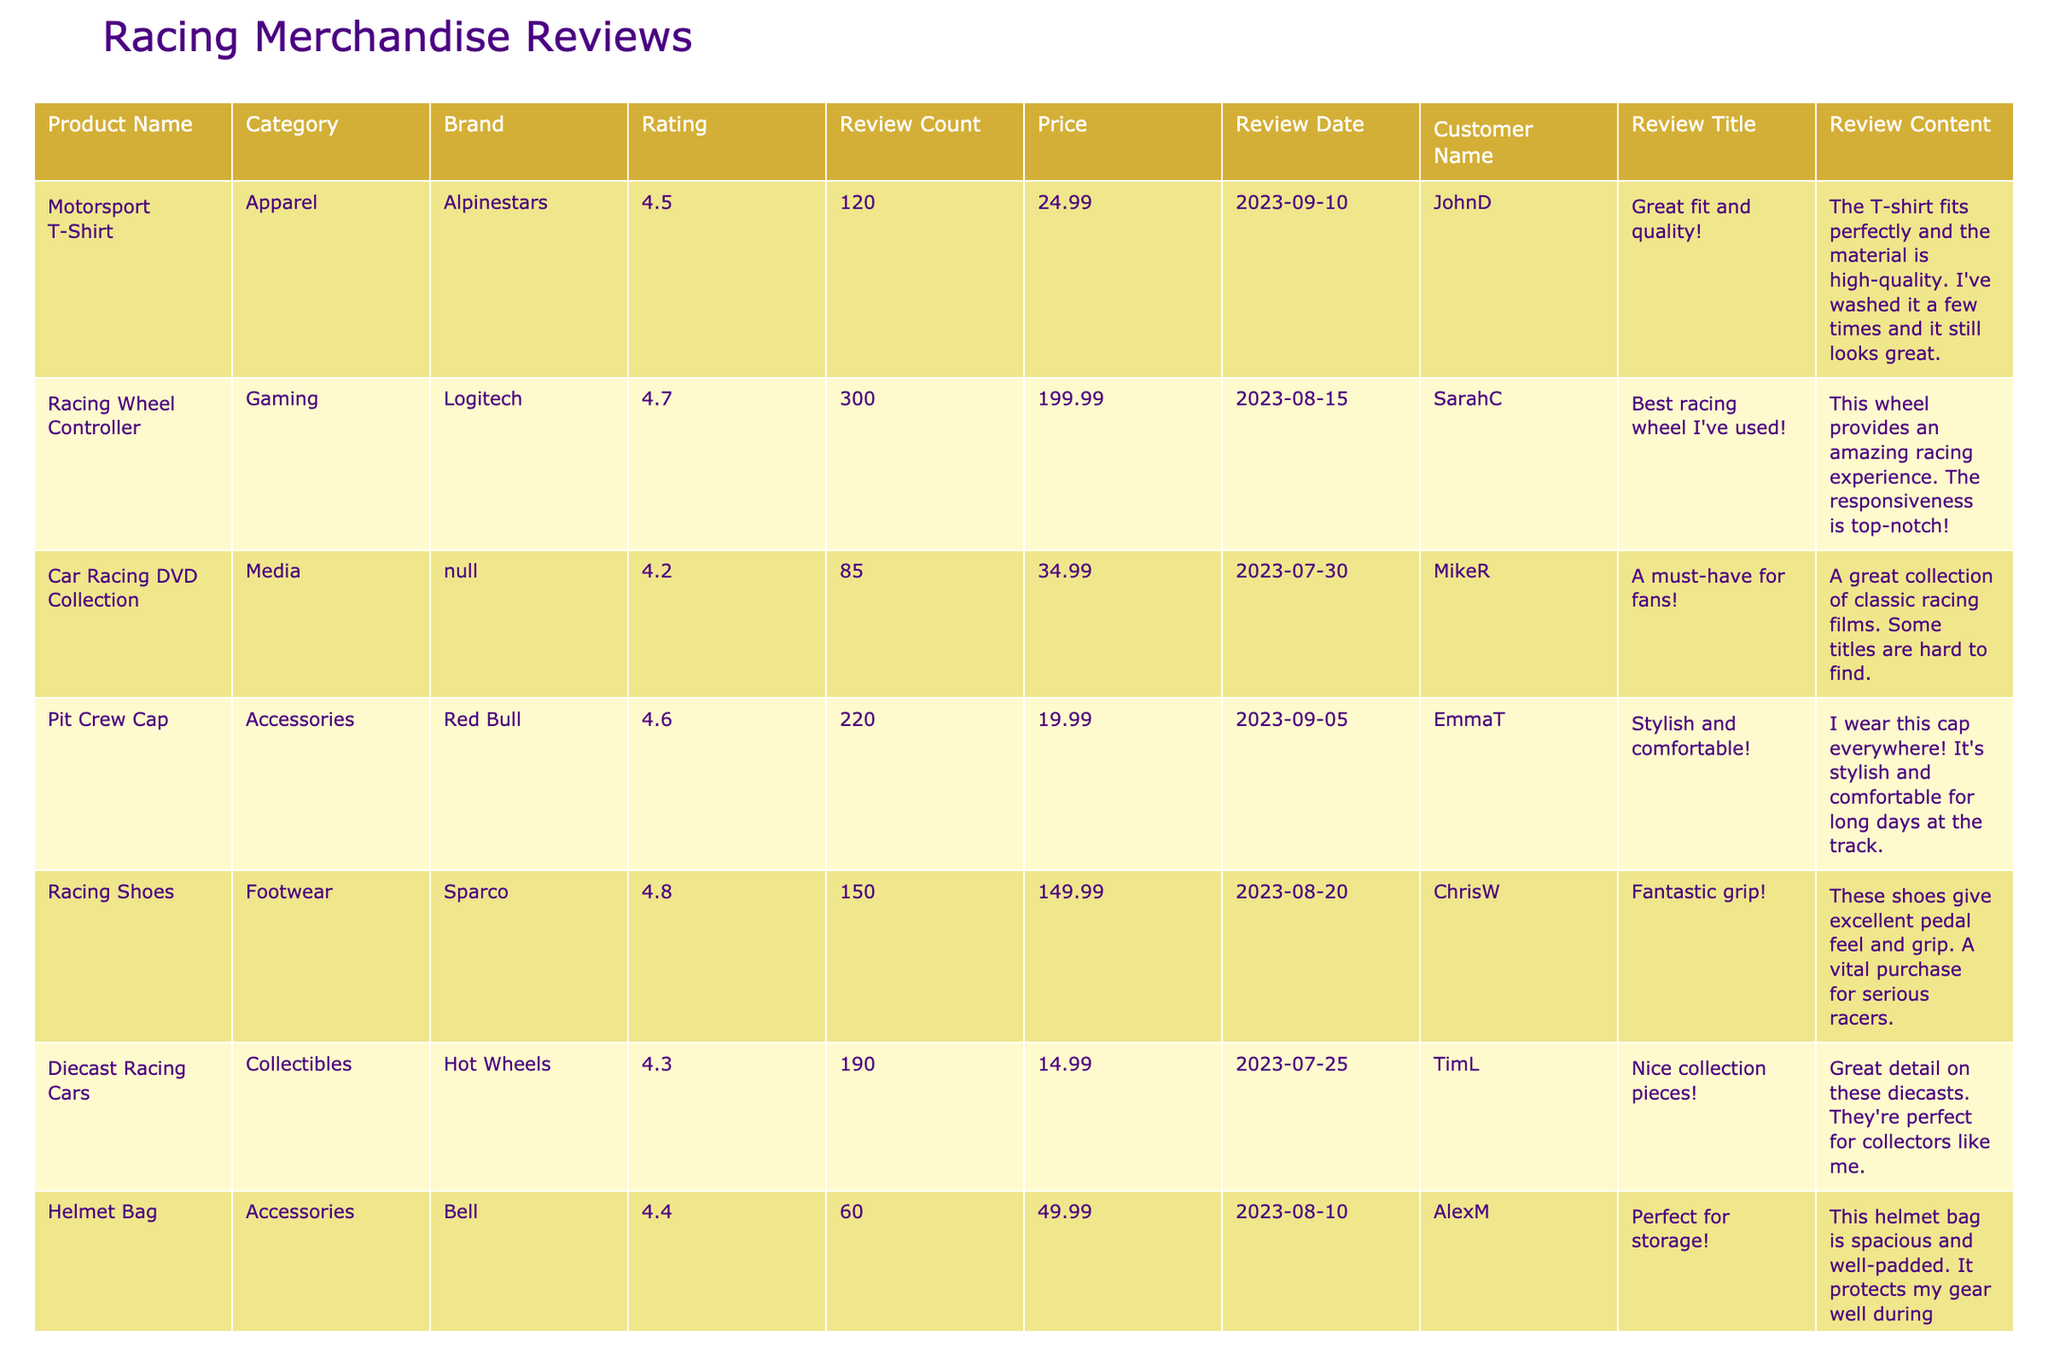What is the average rating of the products listed? To find the average rating, sum all the ratings: 4.5 + 4.7 + 4.2 + 4.6 + 4.8 + 4.3 + 4.4 + 4.6 + 4.1 = 40.2. There are 9 products, so the average rating is 40.2 / 9 ≈ 4.47.
Answer: 4.47 Which product has the highest review count? Looking at the review count column, the product "Racing Wheel Controller" has the highest review count of 300.
Answer: Racing Wheel Controller Is there any product priced above $150? By examining the price column, the only product priced above $150 is the "Racing Shoes," which costs $149.99, so the answer is no.
Answer: No What is the total review count of all products combined? Adding the review counts: 120 + 300 + 85 + 220 + 150 + 190 + 60 + 110 + 50 = 1,525.
Answer: 1525 Which brand has the highest-rated product? The product "Racing Shoes" by Sparco has the highest rating of 4.8, which is the highest rating among all brands listed.
Answer: Sparco How many products have a rating of 4.4 or higher? Counting the products with ratings of 4.4 or higher: "Motorsport T-Shirt," "Racing Wheel Controller," "Pit Crew Cap," "Racing Shoes," "Helmet Bag," and "Refueler Water Bottle" gives us a total of 6 products.
Answer: 6 What is the price difference between the most expensive and the cheapest product? The most expensive product is the "Racing Wheel Controller" at $199.99, and the cheapest is the "Diecast Racing Cars" at $14.99. The price difference is $199.99 - $14.99 = $185.00.
Answer: $185.00 Which product received the oldest review? The review dates are analyzed, and the oldest review date is "2023-06-22," corresponding to the "Motorsport Poster."
Answer: Motorsport Poster Does any product have a review title containing the word "great"? Scanning through the review titles, both "Motorsport T-Shirt" and "Refueler Water Bottle" have review titles that contain the word "great," so the answer is yes.
Answer: Yes What percentage of products have a review count of 100 or more? There are 3 products with a review count of 100 or more: "Racing Wheel Controller," "Pit Crew Cap," and "Refueler Water Bottle," out of 9 total products. Therefore, the percentage is (3/9) * 100 ≈ 33.33%.
Answer: 33.33% 